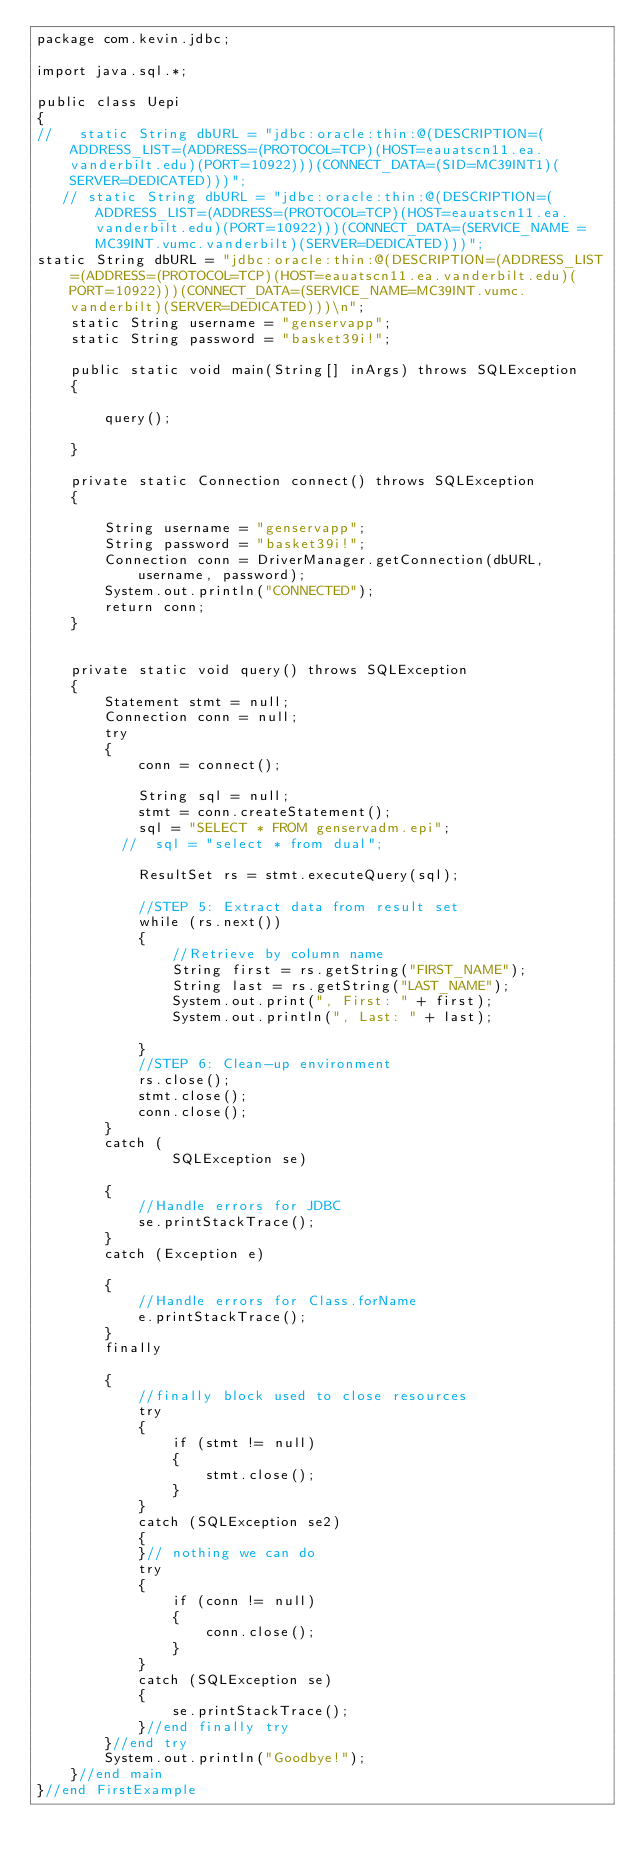<code> <loc_0><loc_0><loc_500><loc_500><_Java_>package com.kevin.jdbc;

import java.sql.*;

public class Uepi
{
//   static String dbURL = "jdbc:oracle:thin:@(DESCRIPTION=(ADDRESS_LIST=(ADDRESS=(PROTOCOL=TCP)(HOST=eauatscn11.ea.vanderbilt.edu)(PORT=10922)))(CONNECT_DATA=(SID=MC39INT1)(SERVER=DEDICATED)))";
   // static String dbURL = "jdbc:oracle:thin:@(DESCRIPTION=(ADDRESS_LIST=(ADDRESS=(PROTOCOL=TCP)(HOST=eauatscn11.ea.vanderbilt.edu)(PORT=10922)))(CONNECT_DATA=(SERVICE_NAME = MC39INT.vumc.vanderbilt)(SERVER=DEDICATED)))";
static String dbURL = "jdbc:oracle:thin:@(DESCRIPTION=(ADDRESS_LIST=(ADDRESS=(PROTOCOL=TCP)(HOST=eauatscn11.ea.vanderbilt.edu)(PORT=10922)))(CONNECT_DATA=(SERVICE_NAME=MC39INT.vumc.vanderbilt)(SERVER=DEDICATED)))\n";
    static String username = "genservapp";
    static String password = "basket39i!";

    public static void main(String[] inArgs) throws SQLException
    {

        query();

    }

    private static Connection connect() throws SQLException
    {

        String username = "genservapp";
        String password = "basket39i!";
        Connection conn = DriverManager.getConnection(dbURL, username, password);
        System.out.println("CONNECTED");
        return conn;
    }


    private static void query() throws SQLException
    {
        Statement stmt = null;
        Connection conn = null;
        try
        {
            conn = connect();

            String sql = null;
            stmt = conn.createStatement();
            sql = "SELECT * FROM genservadm.epi";
          //  sql = "select * from dual";

            ResultSet rs = stmt.executeQuery(sql);

            //STEP 5: Extract data from result set
            while (rs.next())
            {
                //Retrieve by column name
                String first = rs.getString("FIRST_NAME");
                String last = rs.getString("LAST_NAME");
                System.out.print(", First: " + first);
                System.out.println(", Last: " + last);

            }
            //STEP 6: Clean-up environment
            rs.close();
            stmt.close();
            conn.close();
        }
        catch (
                SQLException se)

        {
            //Handle errors for JDBC
            se.printStackTrace();
        }
        catch (Exception e)

        {
            //Handle errors for Class.forName
            e.printStackTrace();
        }
        finally

        {
            //finally block used to close resources
            try
            {
                if (stmt != null)
                {
                    stmt.close();
                }
            }
            catch (SQLException se2)
            {
            }// nothing we can do
            try
            {
                if (conn != null)
                {
                    conn.close();
                }
            }
            catch (SQLException se)
            {
                se.printStackTrace();
            }//end finally try
        }//end try
        System.out.println("Goodbye!");
    }//end main
}//end FirstExample
</code> 